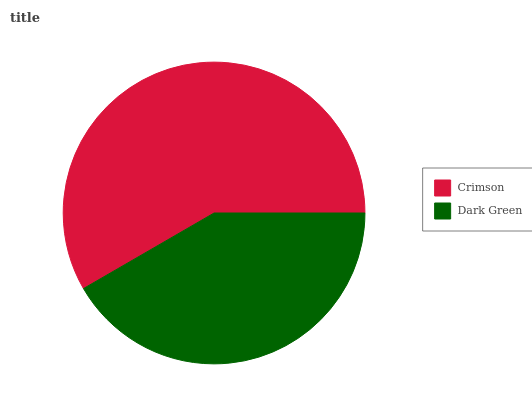Is Dark Green the minimum?
Answer yes or no. Yes. Is Crimson the maximum?
Answer yes or no. Yes. Is Dark Green the maximum?
Answer yes or no. No. Is Crimson greater than Dark Green?
Answer yes or no. Yes. Is Dark Green less than Crimson?
Answer yes or no. Yes. Is Dark Green greater than Crimson?
Answer yes or no. No. Is Crimson less than Dark Green?
Answer yes or no. No. Is Crimson the high median?
Answer yes or no. Yes. Is Dark Green the low median?
Answer yes or no. Yes. Is Dark Green the high median?
Answer yes or no. No. Is Crimson the low median?
Answer yes or no. No. 